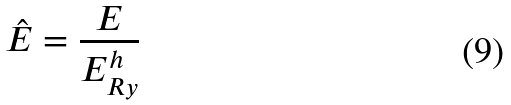<formula> <loc_0><loc_0><loc_500><loc_500>\hat { E } = \frac { E } { E _ { R y } ^ { h } }</formula> 